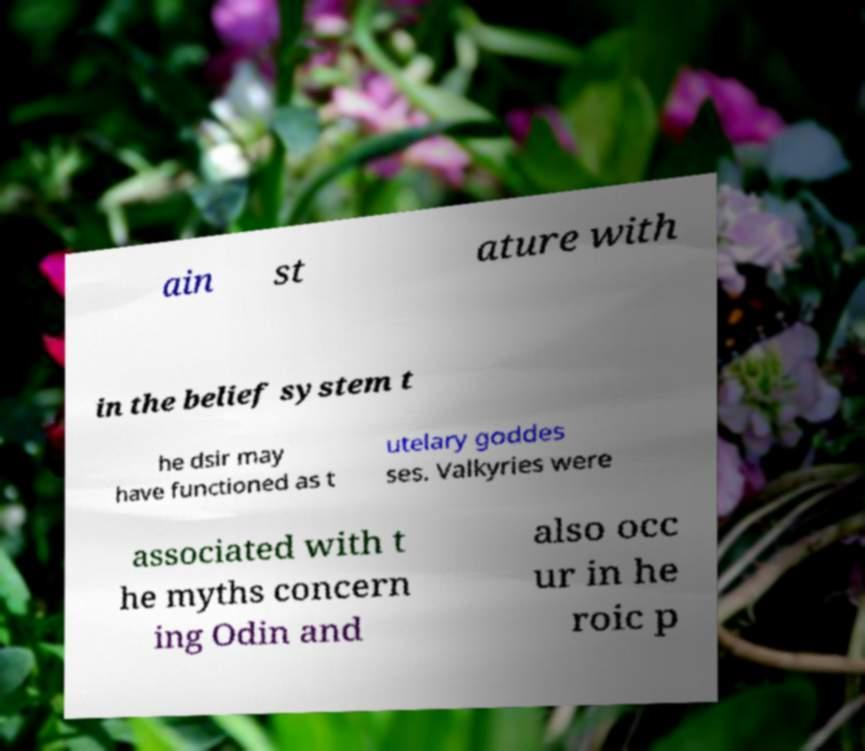There's text embedded in this image that I need extracted. Can you transcribe it verbatim? ain st ature with in the belief system t he dsir may have functioned as t utelary goddes ses. Valkyries were associated with t he myths concern ing Odin and also occ ur in he roic p 